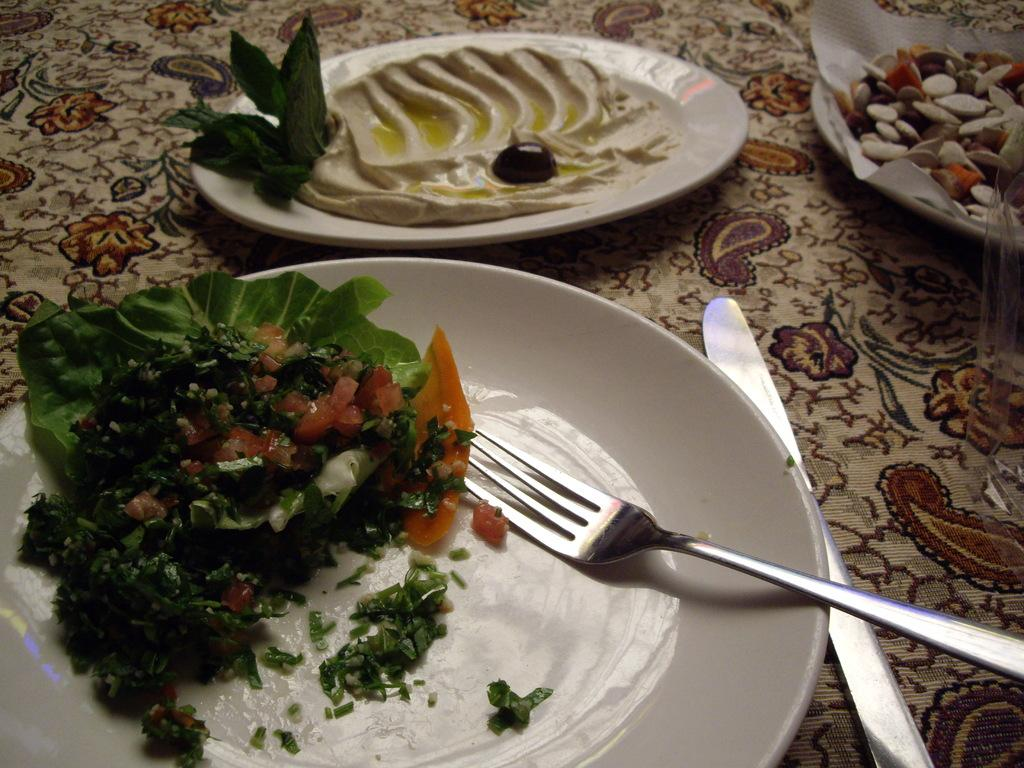What is covering the surface in the image? There is a cloth in the image. What can be found on the cloth? There are plates with food items on the cloth. What utensils are visible in the image? There is a spoon and a knife visible in the image. What type of paper is present in the image? There is a paper in the image. Can you describe any other objects present in the image? There are other objects present in the image, but their specific details are not mentioned in the provided facts. What type of lumber is being used as a table in the image? There is no table or lumber present in the image; it features a cloth with plates and utensils. What type of office supplies can be seen in the image? There are no office supplies present in the image. 